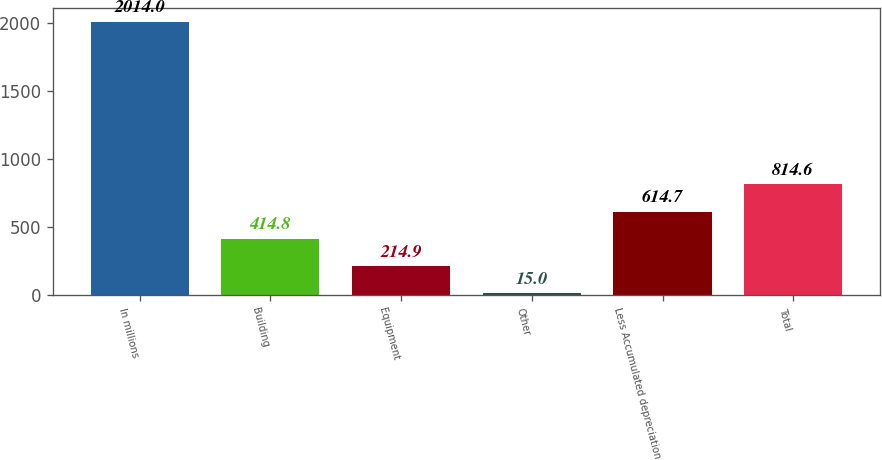<chart> <loc_0><loc_0><loc_500><loc_500><bar_chart><fcel>In millions<fcel>Building<fcel>Equipment<fcel>Other<fcel>Less Accumulated depreciation<fcel>Total<nl><fcel>2014<fcel>414.8<fcel>214.9<fcel>15<fcel>614.7<fcel>814.6<nl></chart> 